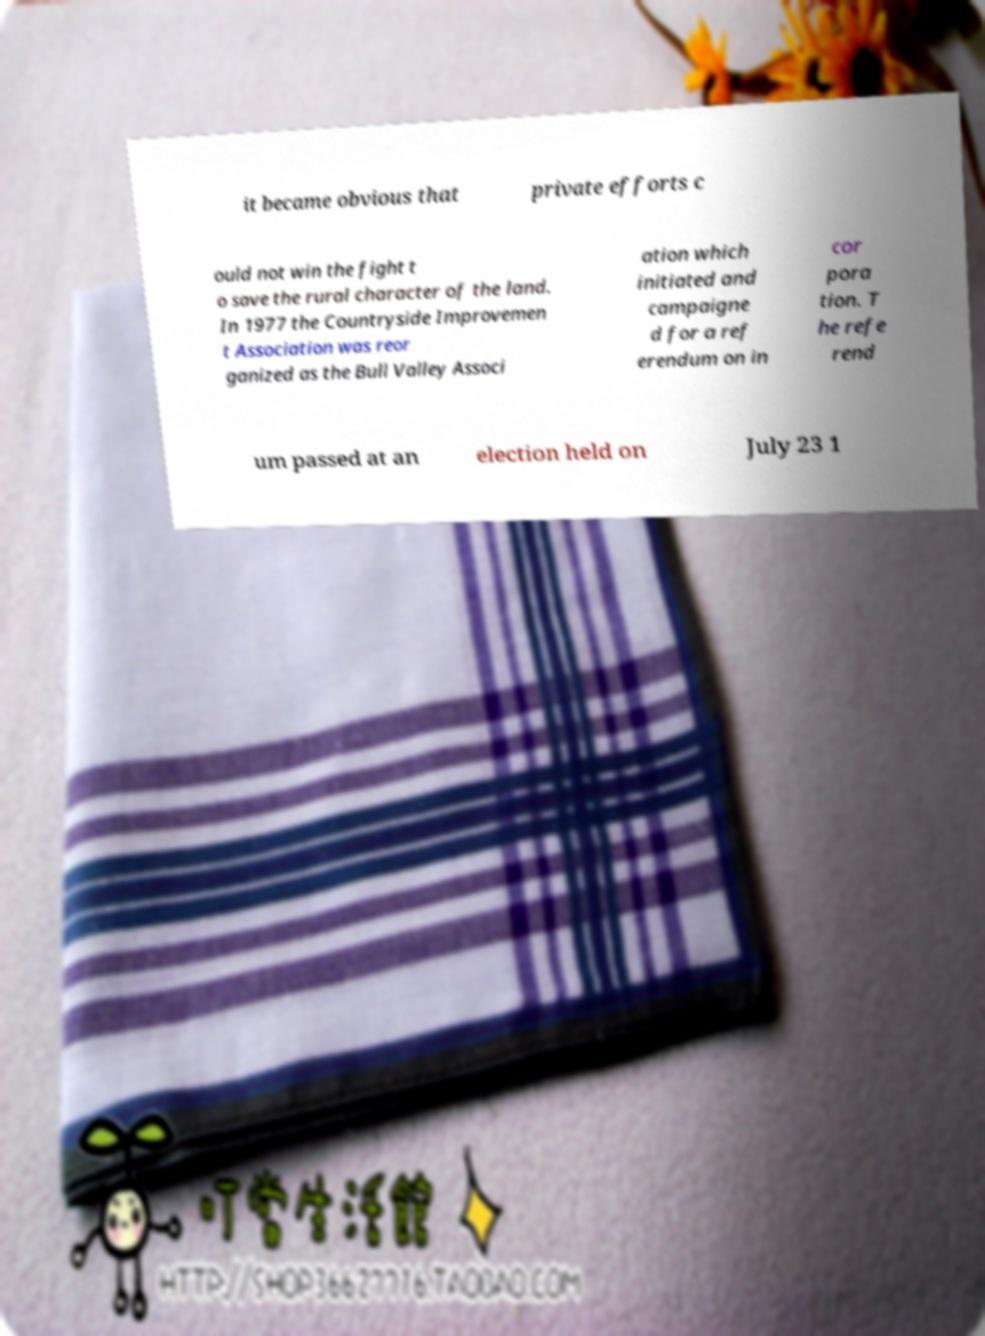What messages or text are displayed in this image? I need them in a readable, typed format. it became obvious that private efforts c ould not win the fight t o save the rural character of the land. In 1977 the Countryside Improvemen t Association was reor ganized as the Bull Valley Associ ation which initiated and campaigne d for a ref erendum on in cor pora tion. T he refe rend um passed at an election held on July 23 1 